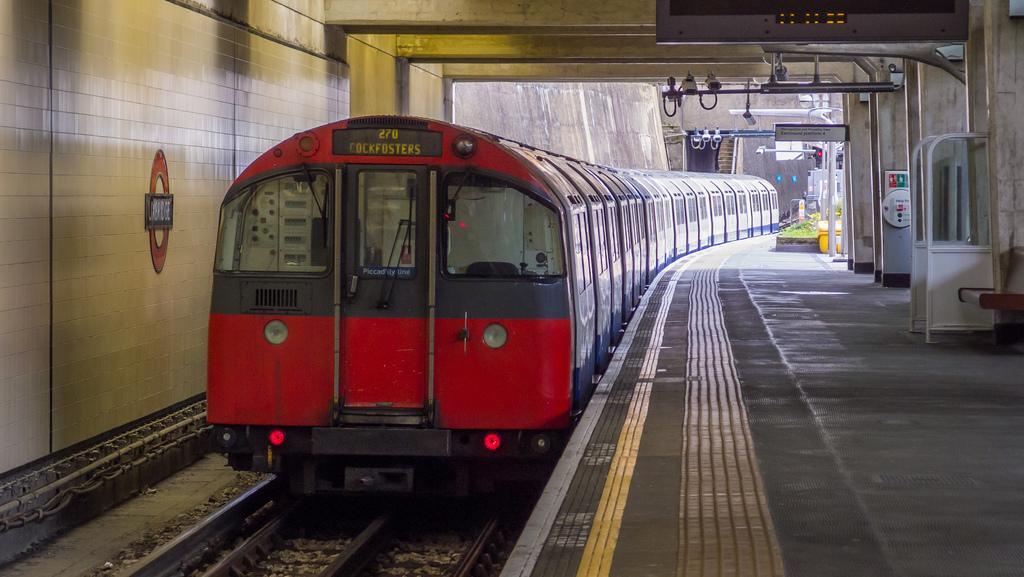How would you summarize this image in a sentence or two? In this image we can see a train on the track. There is a platform and we can see boards. On the right there is a bench. 